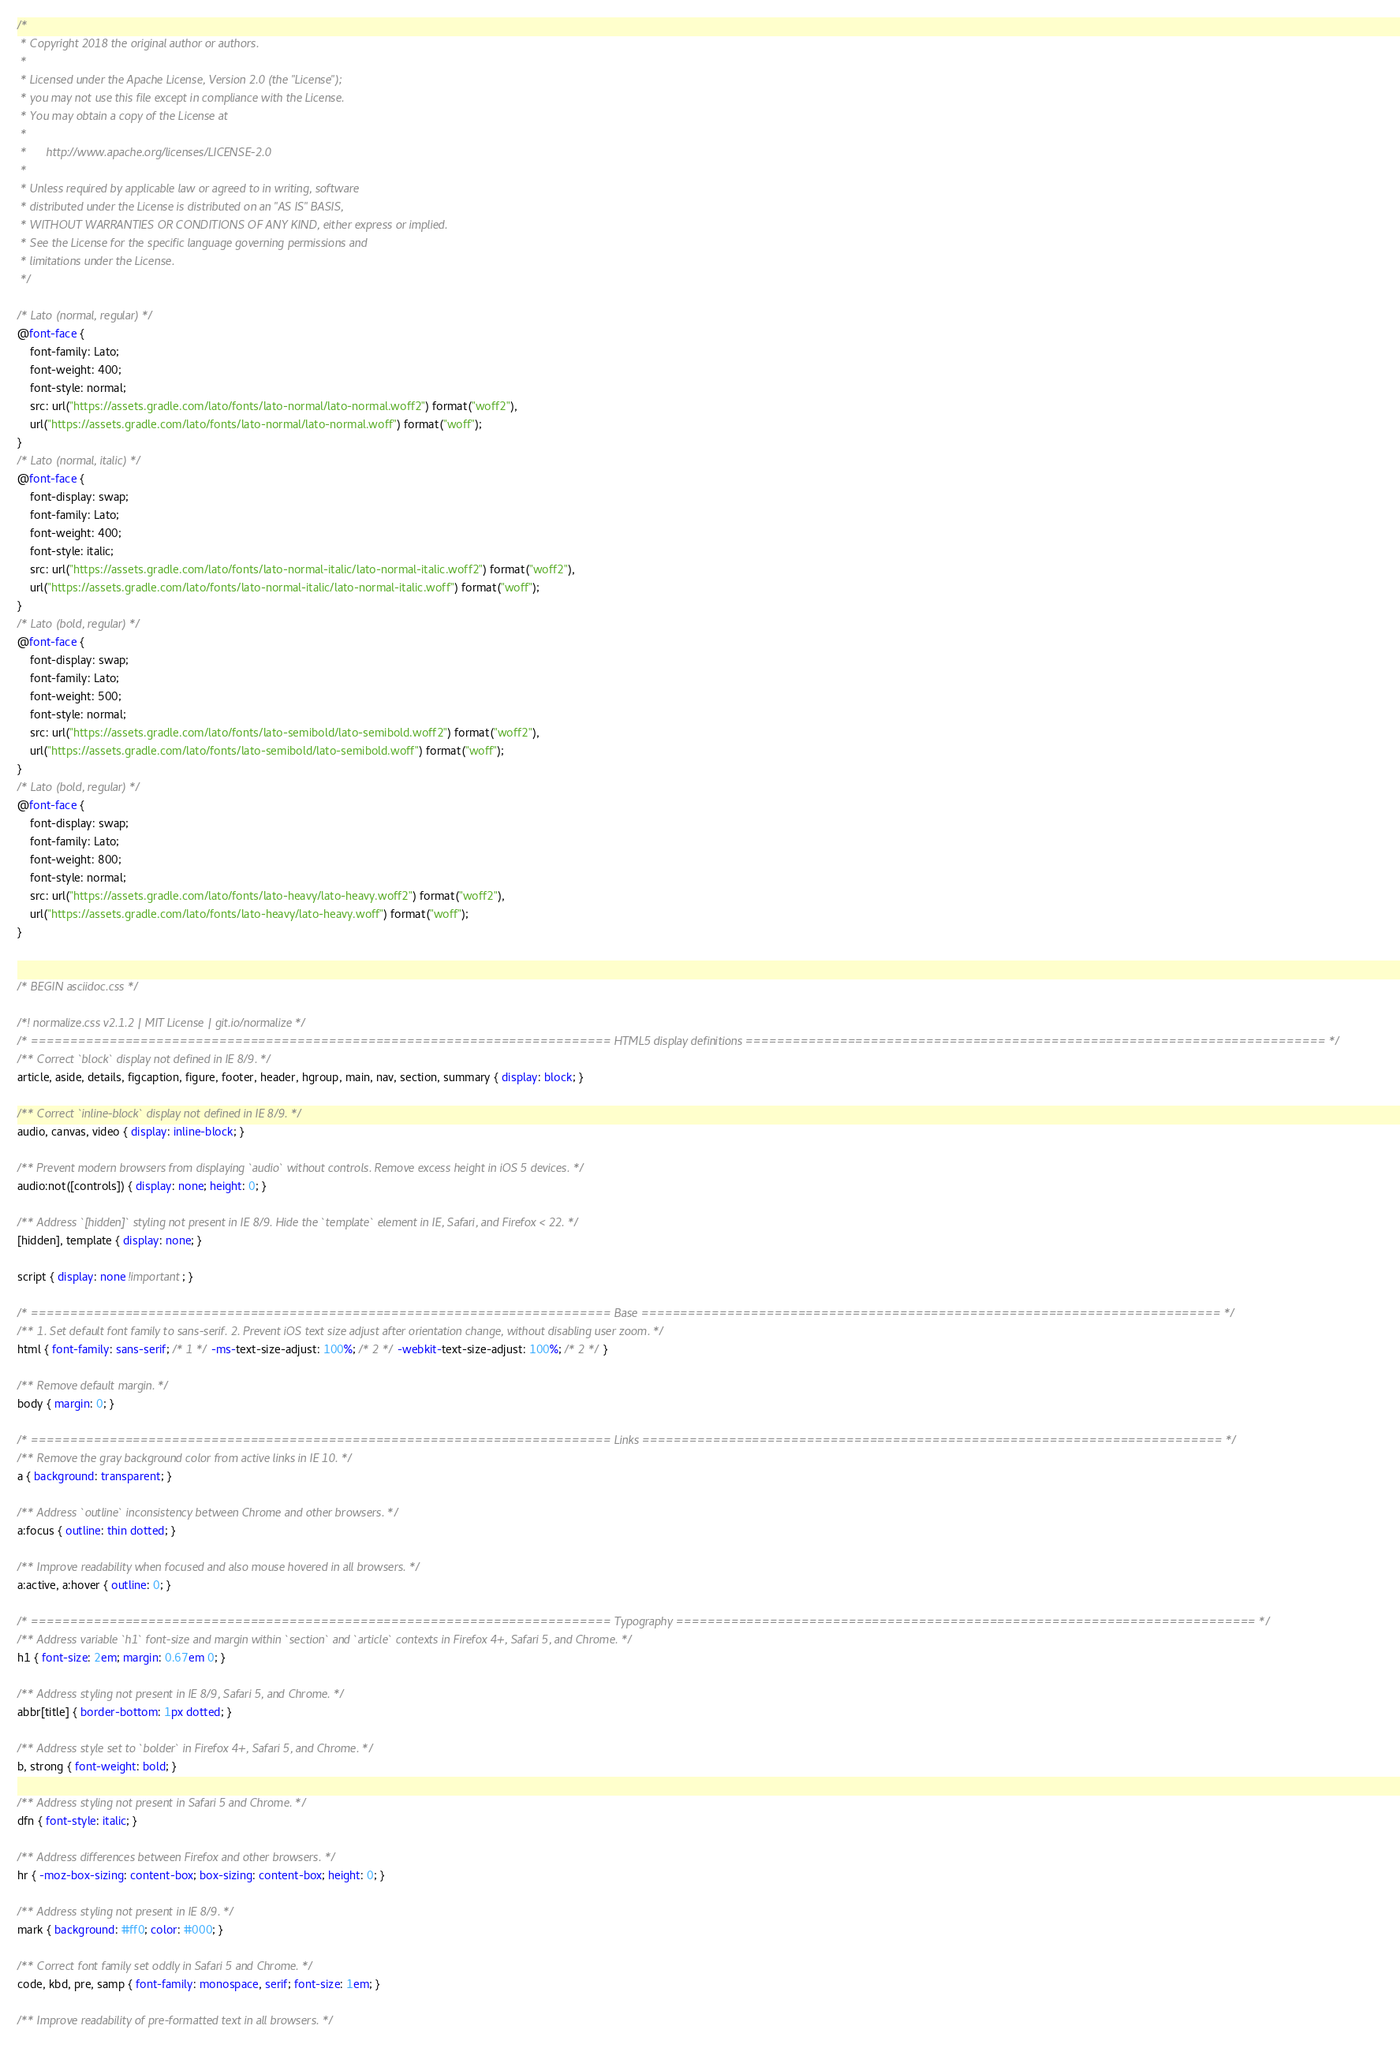Convert code to text. <code><loc_0><loc_0><loc_500><loc_500><_CSS_>/*
 * Copyright 2018 the original author or authors.
 *
 * Licensed under the Apache License, Version 2.0 (the "License");
 * you may not use this file except in compliance with the License.
 * You may obtain a copy of the License at
 *
 *      http://www.apache.org/licenses/LICENSE-2.0
 *
 * Unless required by applicable law or agreed to in writing, software
 * distributed under the License is distributed on an "AS IS" BASIS,
 * WITHOUT WARRANTIES OR CONDITIONS OF ANY KIND, either express or implied.
 * See the License for the specific language governing permissions and
 * limitations under the License.
 */

/* Lato (normal, regular) */
@font-face {
    font-family: Lato;
    font-weight: 400;
    font-style: normal;
    src: url("https://assets.gradle.com/lato/fonts/lato-normal/lato-normal.woff2") format("woff2"),
    url("https://assets.gradle.com/lato/fonts/lato-normal/lato-normal.woff") format("woff");
}
/* Lato (normal, italic) */
@font-face {
    font-display: swap;
    font-family: Lato;
    font-weight: 400;
    font-style: italic;
    src: url("https://assets.gradle.com/lato/fonts/lato-normal-italic/lato-normal-italic.woff2") format("woff2"),
    url("https://assets.gradle.com/lato/fonts/lato-normal-italic/lato-normal-italic.woff") format("woff");
}
/* Lato (bold, regular) */
@font-face {
    font-display: swap;
    font-family: Lato;
    font-weight: 500;
    font-style: normal;
    src: url("https://assets.gradle.com/lato/fonts/lato-semibold/lato-semibold.woff2") format("woff2"),
    url("https://assets.gradle.com/lato/fonts/lato-semibold/lato-semibold.woff") format("woff");
}
/* Lato (bold, regular) */
@font-face {
    font-display: swap;
    font-family: Lato;
    font-weight: 800;
    font-style: normal;
    src: url("https://assets.gradle.com/lato/fonts/lato-heavy/lato-heavy.woff2") format("woff2"),
    url("https://assets.gradle.com/lato/fonts/lato-heavy/lato-heavy.woff") format("woff");
}


/* BEGIN asciidoc.css */

/*! normalize.css v2.1.2 | MIT License | git.io/normalize */
/* ========================================================================== HTML5 display definitions ========================================================================== */
/** Correct `block` display not defined in IE 8/9. */
article, aside, details, figcaption, figure, footer, header, hgroup, main, nav, section, summary { display: block; }

/** Correct `inline-block` display not defined in IE 8/9. */
audio, canvas, video { display: inline-block; }

/** Prevent modern browsers from displaying `audio` without controls. Remove excess height in iOS 5 devices. */
audio:not([controls]) { display: none; height: 0; }

/** Address `[hidden]` styling not present in IE 8/9. Hide the `template` element in IE, Safari, and Firefox < 22. */
[hidden], template { display: none; }

script { display: none !important; }

/* ========================================================================== Base ========================================================================== */
/** 1. Set default font family to sans-serif. 2. Prevent iOS text size adjust after orientation change, without disabling user zoom. */
html { font-family: sans-serif; /* 1 */ -ms-text-size-adjust: 100%; /* 2 */ -webkit-text-size-adjust: 100%; /* 2 */ }

/** Remove default margin. */
body { margin: 0; }

/* ========================================================================== Links ========================================================================== */
/** Remove the gray background color from active links in IE 10. */
a { background: transparent; }

/** Address `outline` inconsistency between Chrome and other browsers. */
a:focus { outline: thin dotted; }

/** Improve readability when focused and also mouse hovered in all browsers. */
a:active, a:hover { outline: 0; }

/* ========================================================================== Typography ========================================================================== */
/** Address variable `h1` font-size and margin within `section` and `article` contexts in Firefox 4+, Safari 5, and Chrome. */
h1 { font-size: 2em; margin: 0.67em 0; }

/** Address styling not present in IE 8/9, Safari 5, and Chrome. */
abbr[title] { border-bottom: 1px dotted; }

/** Address style set to `bolder` in Firefox 4+, Safari 5, and Chrome. */
b, strong { font-weight: bold; }

/** Address styling not present in Safari 5 and Chrome. */
dfn { font-style: italic; }

/** Address differences between Firefox and other browsers. */
hr { -moz-box-sizing: content-box; box-sizing: content-box; height: 0; }

/** Address styling not present in IE 8/9. */
mark { background: #ff0; color: #000; }

/** Correct font family set oddly in Safari 5 and Chrome. */
code, kbd, pre, samp { font-family: monospace, serif; font-size: 1em; }

/** Improve readability of pre-formatted text in all browsers. */</code> 